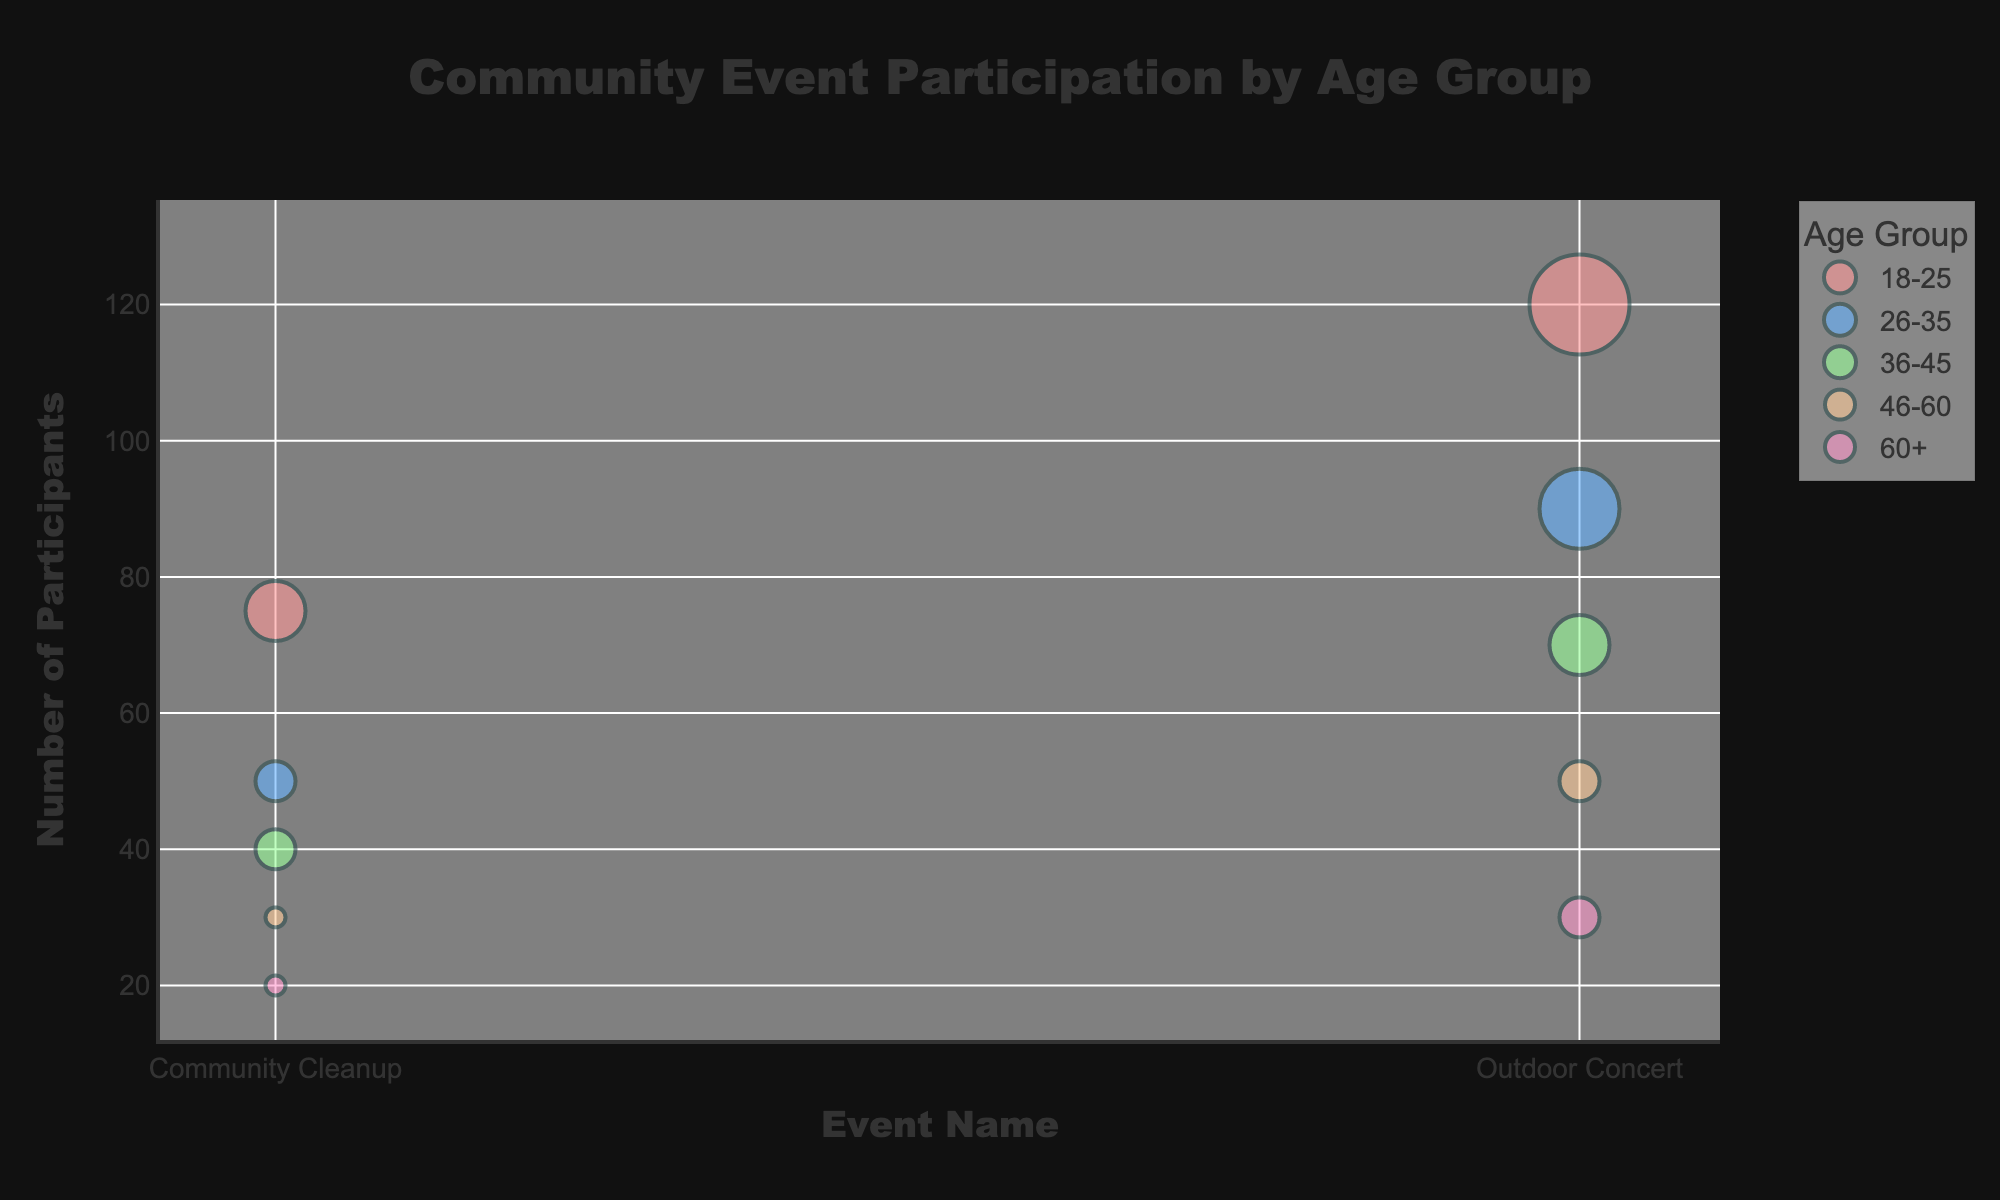What is the title of the figure? The title is located at the top of the bubble chart. It provides a summary of the figure's purpose. In this case, the title is "Community Event Participation by Age Group".
Answer: Community Event Participation by Age Group Which age group has the highest number of participants in the "Outdoor Concert"? To determine this, look at the "Outdoor Concert" section on the x-axis and find the highest bubble on the y-axis, then note the age group represented by the color. The highest bubble corresponds to the 18-25 age group.
Answer: 18-25 What is the total number of participants in "Community Cleanup" for all age groups? Sum the number of participants from each age group for the "Community Cleanup" event. This involves adding 75 (18-25) + 50 (26-35) + 40 (36-45) + 30 (46-60) + 20 (60+).
Answer: 215 Which event has more participants in the 26-35 age group, "Community Cleanup" or "Outdoor Concert"? Compare the bubbles for the 26-35 age group in the "Community Cleanup" and "Outdoor Concert" sections. The bubble for "Outdoor Concert" is higher, indicating more participants.
Answer: Outdoor Concert Among the age groups, which had the smallest average participation frequency for "Outdoor Concert"? Check the size of the bubbles in the "Outdoor Concert" section for each age group. The smallest bubble corresponds to the 46-60 age group. The size of the bubble indicates the average participation frequency, which is smallest (2) for 46-60.
Answer: 46-60 What is the average participation frequency for the 18-25 age group in all events? Note the average participation frequency for each event in the 18-25 age group. There are two events: "Community Cleanup" (3) and "Outdoor Concert" (5). Calculate the average: (3 + 5) / 2 = 4.
Answer: 4 Does the 60+ age group participate more in "Community Cleanup" or "Outdoor Concert"? Check the y-axis positions of the bubbles for the 60+ age group in both event sections. The higher bubble in "Outdoor Concert" (30 participants) indicates more participation compared to "Community Cleanup" (20 participants).
Answer: Outdoor Concert How does the number of participants in "Community Cleanup" for the 36-45 age group compare to that for the 46-60 age group? Compare the y-axis positions of the bubbles for "Community Cleanup" between the 36-45 and 46-60 age groups. The 36-45 age group has a higher position (40 participants) compared to the 46-60 age group (30 participants).
Answer: 36-45 Which age group has the largest bubble size in the "Community Cleanup" event, and what does it indicate? Find the largest bubble in the "Community Cleanup" event and identify its age group. The largest bubble corresponds to the 18-25 age group, indicating the highest average participation frequency value of 3 for that event.
Answer: 18-25 What is the sum of average participation frequencies for the 26-35 age group across both events? Add the average participation frequencies for the 26-35 age group in "Community Cleanup" (2) and "Outdoor Concert" (4). The sum is 2 + 4 = 6.
Answer: 6 